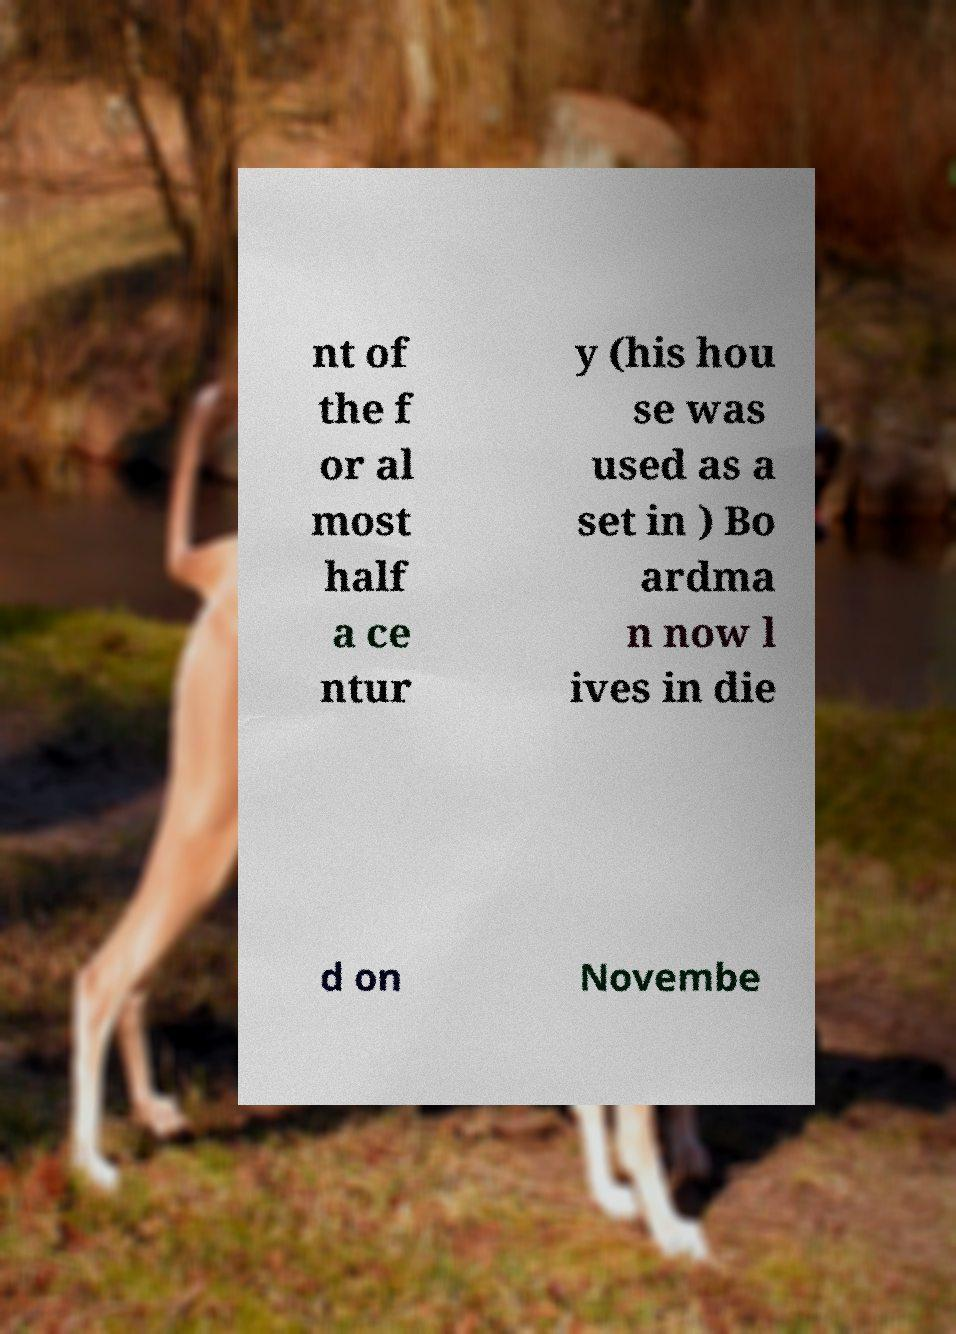Could you assist in decoding the text presented in this image and type it out clearly? nt of the f or al most half a ce ntur y (his hou se was used as a set in ) Bo ardma n now l ives in die d on Novembe 